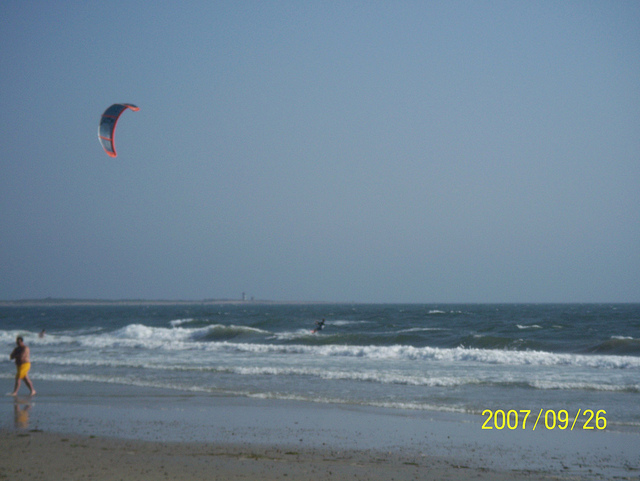Read and extract the text from this image. 2007/09/26 